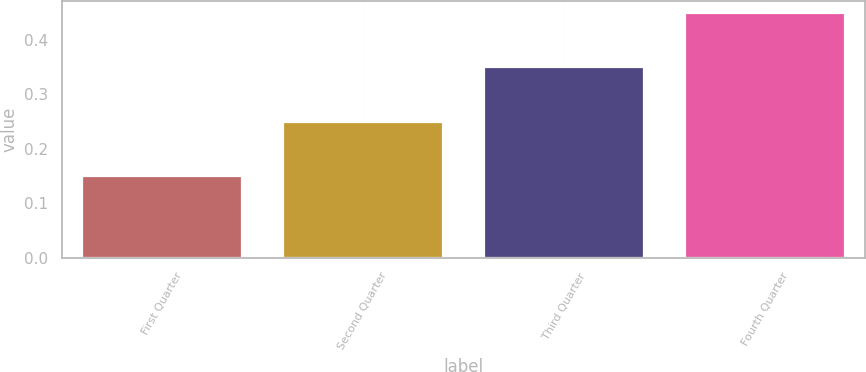Convert chart to OTSL. <chart><loc_0><loc_0><loc_500><loc_500><bar_chart><fcel>First Quarter<fcel>Second Quarter<fcel>Third Quarter<fcel>Fourth Quarter<nl><fcel>0.15<fcel>0.25<fcel>0.35<fcel>0.45<nl></chart> 